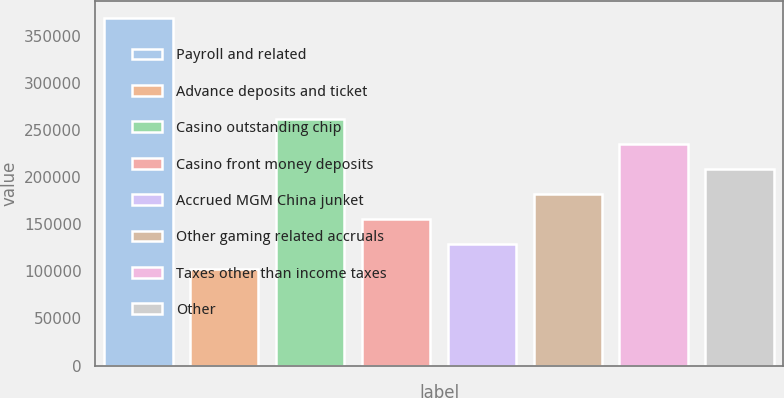Convert chart to OTSL. <chart><loc_0><loc_0><loc_500><loc_500><bar_chart><fcel>Payroll and related<fcel>Advance deposits and ticket<fcel>Casino outstanding chip<fcel>Casino front money deposits<fcel>Accrued MGM China junket<fcel>Other gaming related accruals<fcel>Taxes other than income taxes<fcel>Other<nl><fcel>368702<fcel>102428<fcel>262192<fcel>155683<fcel>129055<fcel>182310<fcel>235565<fcel>208938<nl></chart> 